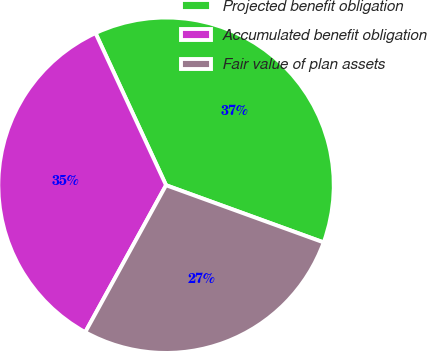Convert chart. <chart><loc_0><loc_0><loc_500><loc_500><pie_chart><fcel>Projected benefit obligation<fcel>Accumulated benefit obligation<fcel>Fair value of plan assets<nl><fcel>37.45%<fcel>35.09%<fcel>27.46%<nl></chart> 